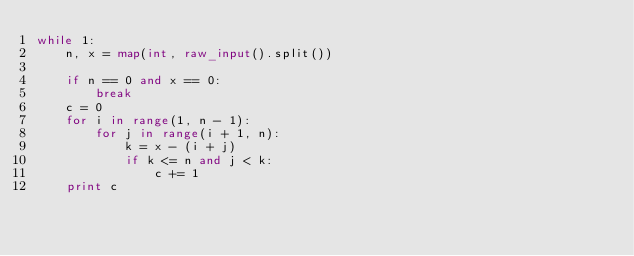<code> <loc_0><loc_0><loc_500><loc_500><_Python_>while 1:
    n, x = map(int, raw_input().split())

    if n == 0 and x == 0:
        break
    c = 0
    for i in range(1, n - 1):
        for j in range(i + 1, n):
            k = x - (i + j)
            if k <= n and j < k:
                c += 1
    print c</code> 